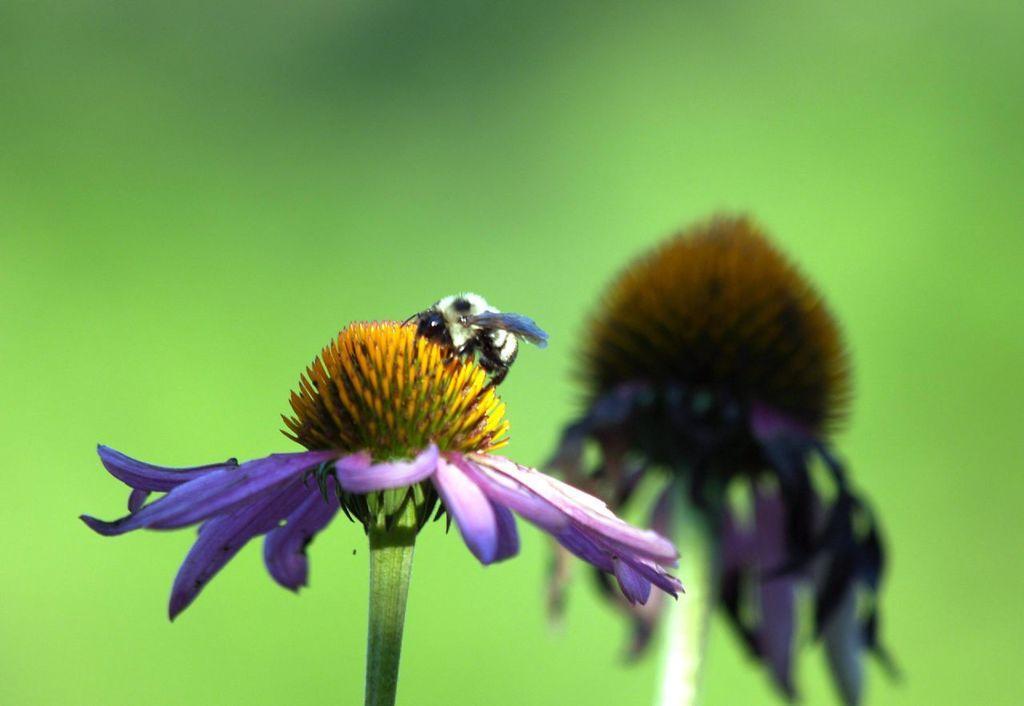Could you give a brief overview of what you see in this image? In the picture we can see a flower with violet color petals to it and in the middle we can see a bud with stamens and on it we can see an insect and behind it, we can see another flower with dried petals and behind it we can see the green color surface. 